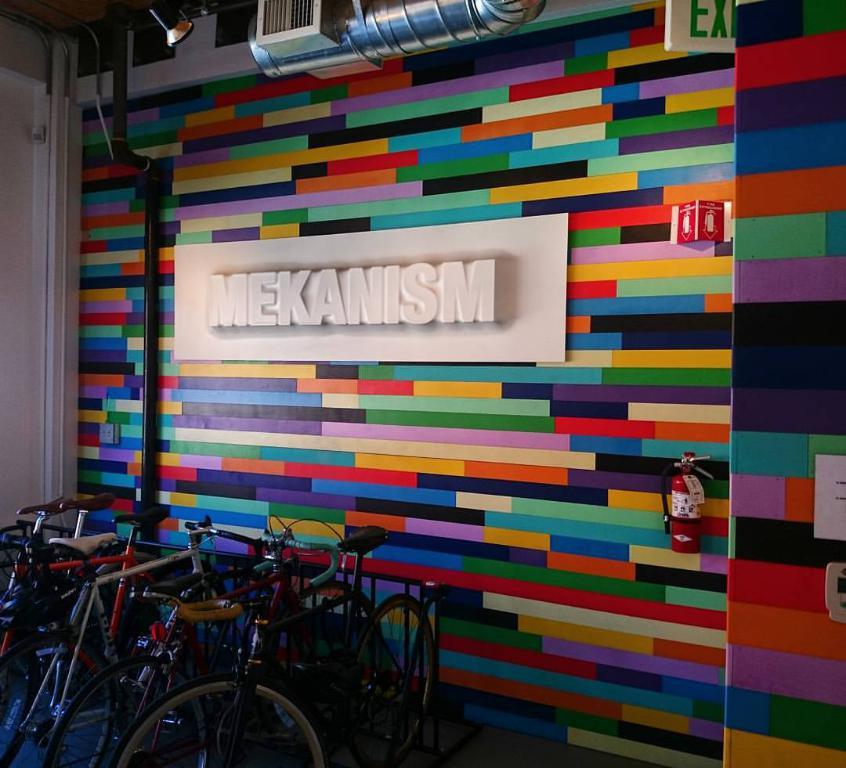<image>
Share a concise interpretation of the image provided. a wall that has a white sign on it that says 'mekanism' 